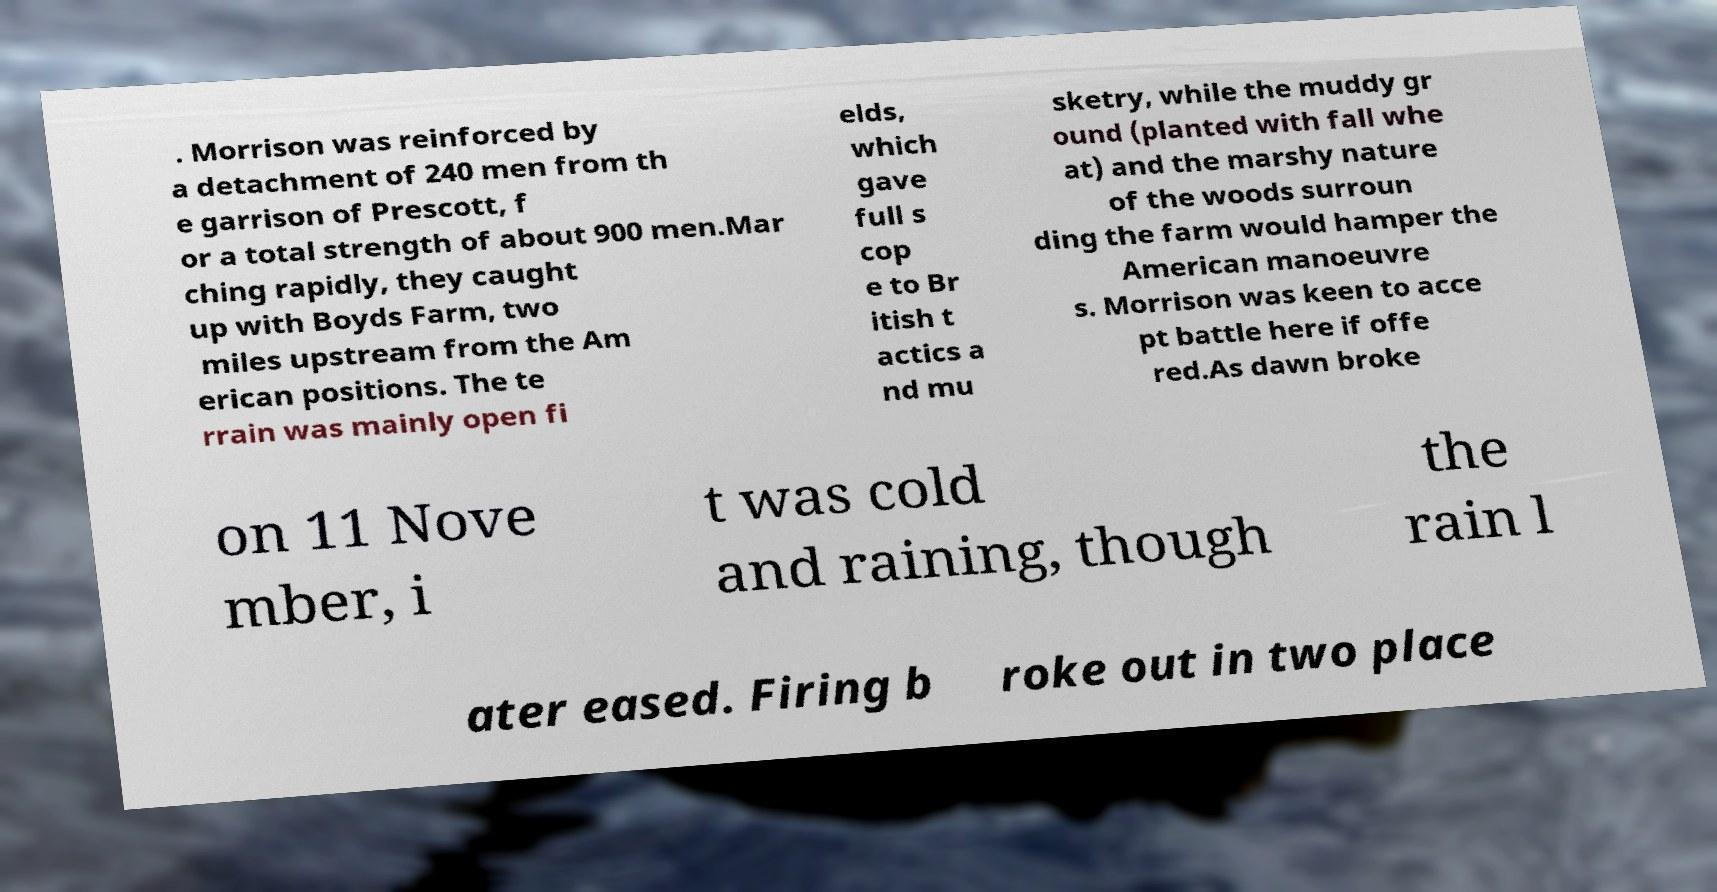I need the written content from this picture converted into text. Can you do that? . Morrison was reinforced by a detachment of 240 men from th e garrison of Prescott, f or a total strength of about 900 men.Mar ching rapidly, they caught up with Boyds Farm, two miles upstream from the Am erican positions. The te rrain was mainly open fi elds, which gave full s cop e to Br itish t actics a nd mu sketry, while the muddy gr ound (planted with fall whe at) and the marshy nature of the woods surroun ding the farm would hamper the American manoeuvre s. Morrison was keen to acce pt battle here if offe red.As dawn broke on 11 Nove mber, i t was cold and raining, though the rain l ater eased. Firing b roke out in two place 